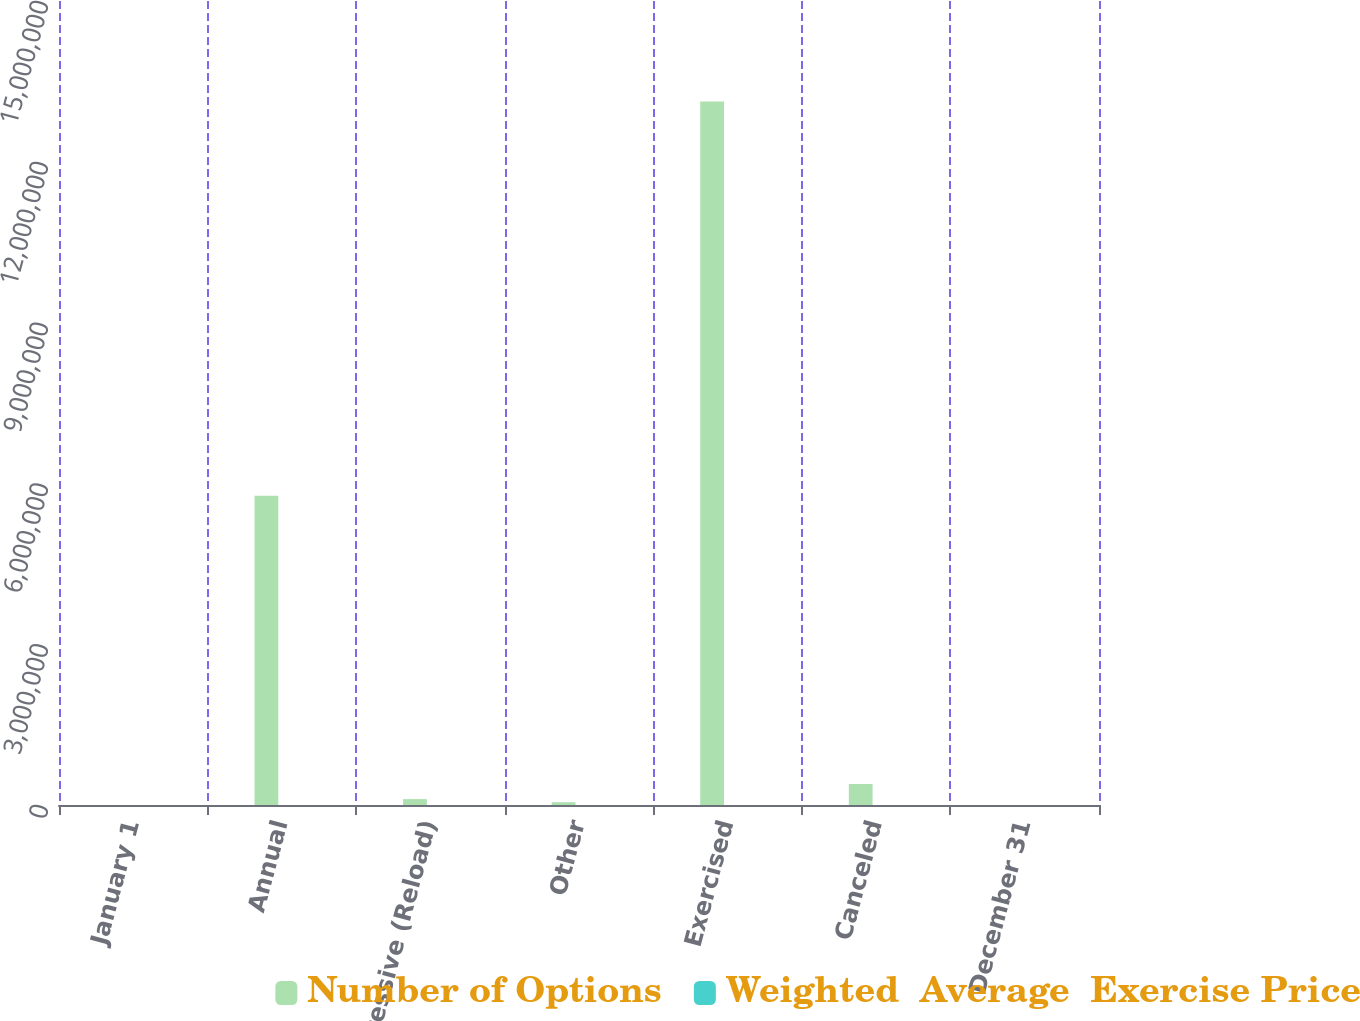Convert chart. <chart><loc_0><loc_0><loc_500><loc_500><stacked_bar_chart><ecel><fcel>January 1<fcel>Annual<fcel>Progressive (Reload)<fcel>Other<fcel>Exercised<fcel>Canceled<fcel>December 31<nl><fcel>Number of Options<fcel>89.45<fcel>5.77019e+06<fcel>110065<fcel>51661<fcel>1.31236e+07<fcel>391684<fcel>89.45<nl><fcel>Weighted  Average  Exercise Price<fcel>77.28<fcel>87.91<fcel>89.65<fcel>89.25<fcel>68.78<fcel>83.65<fcel>80.33<nl></chart> 